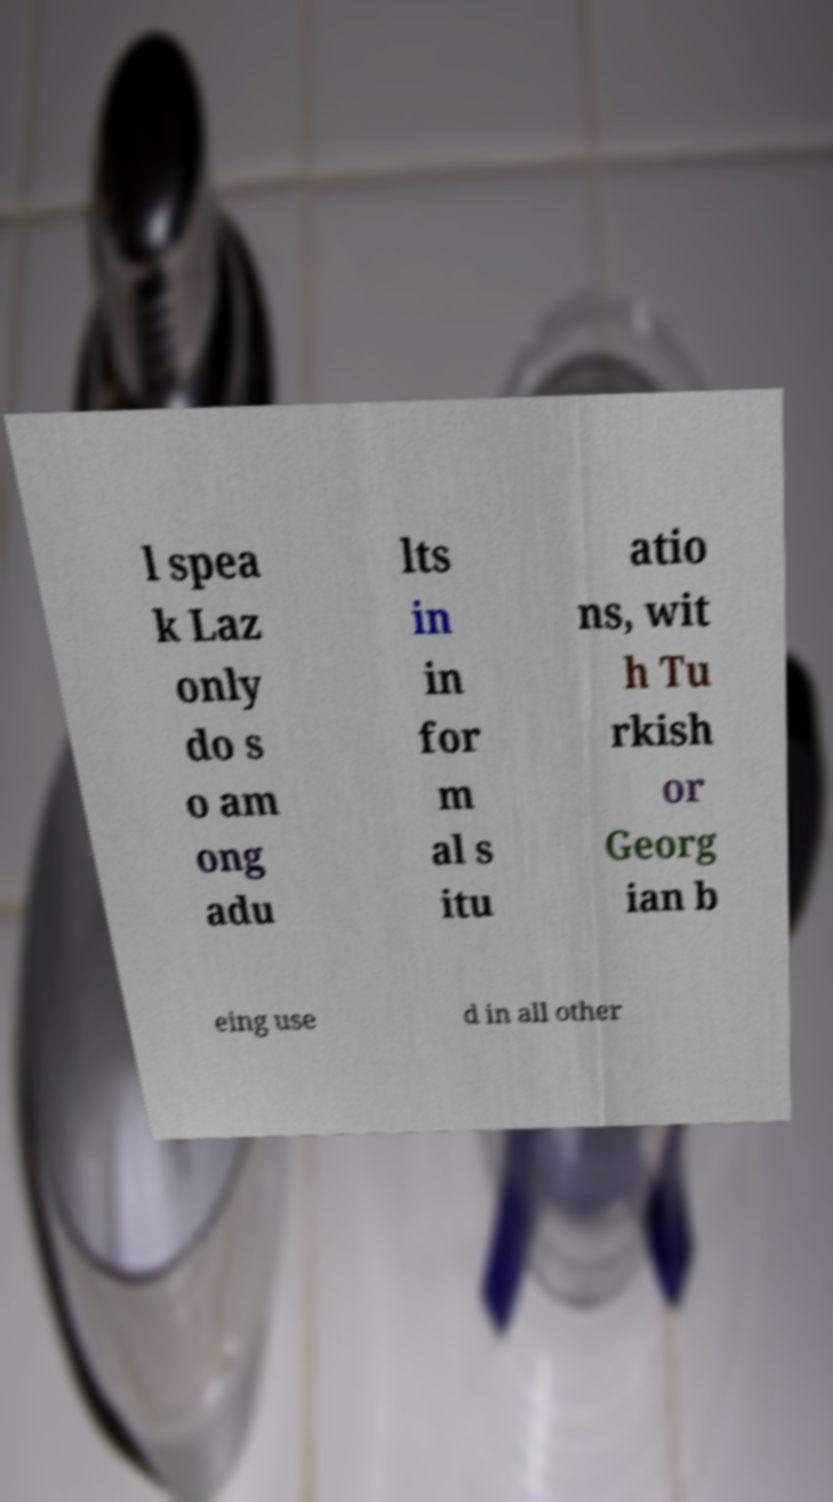Please identify and transcribe the text found in this image. l spea k Laz only do s o am ong adu lts in in for m al s itu atio ns, wit h Tu rkish or Georg ian b eing use d in all other 